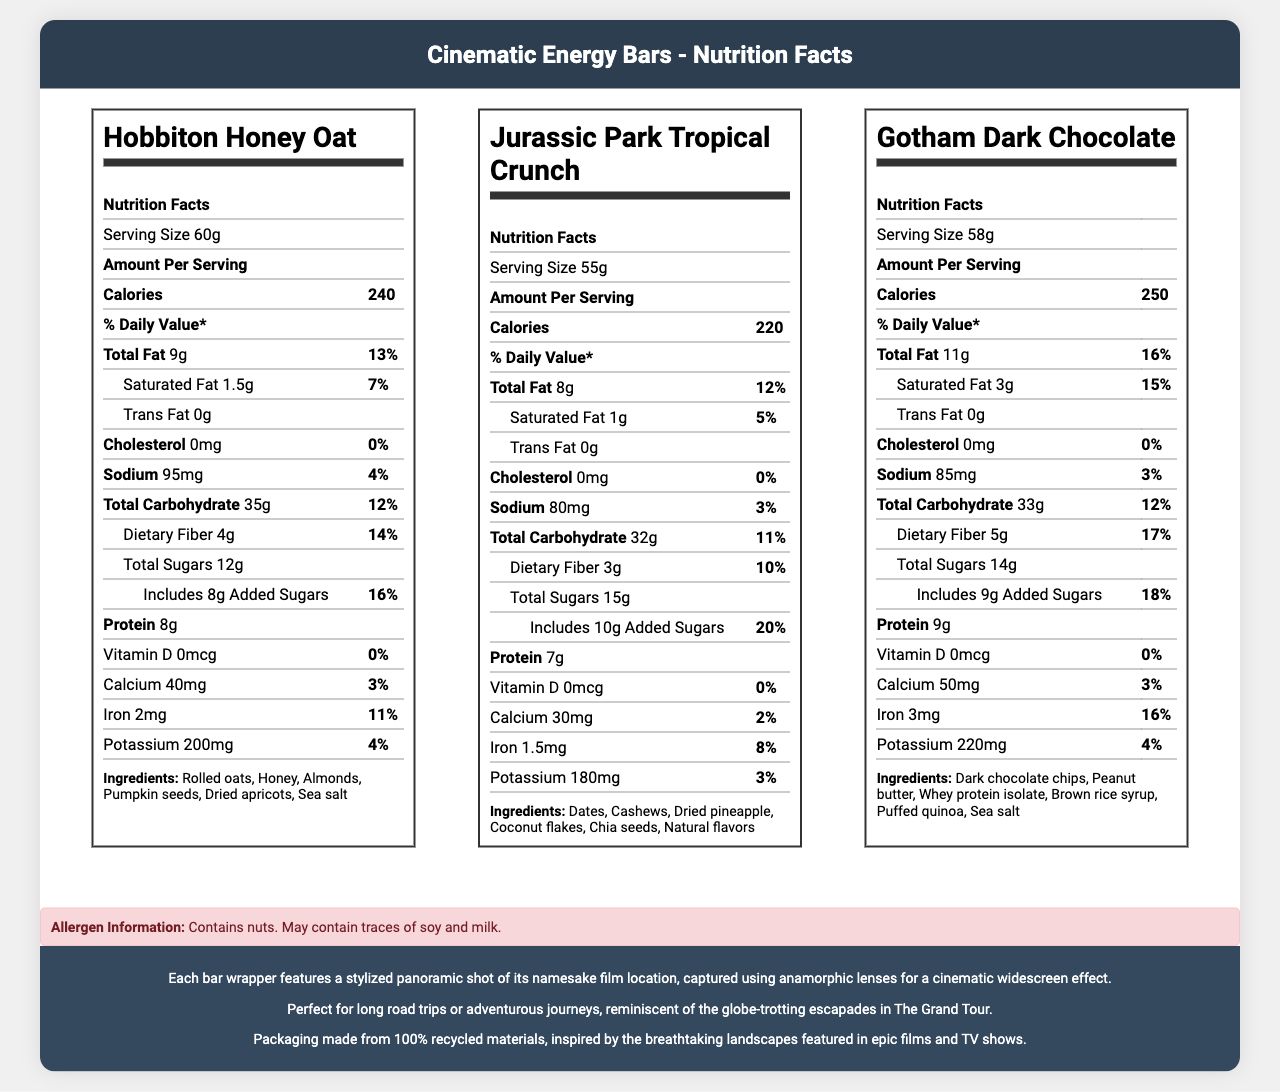what is the serving size of Hobbiton Honey Oat? The serving size is mentioned at the top of the nutritional information for Hobbiton Honey Oat.
Answer: 60g How many calories does the Jurassic Park Tropical Crunch bar have? The number of calories is listed in the nutritional information for the Jurassic Park Tropical Crunch bar.
Answer: 220 What is the protein content of the Gotham Dark Chocolate bar? The protein content is listed in the nutritional information for the Gotham Dark Chocolate bar.
Answer: 9g How much dietary fiber is in the Hobbiton Honey Oat flavor? The dietary fiber content is listed in the nutritional information for the Hobbiton Honey Oat bar.
Answer: 4g What are the main ingredients in the Jurassic Park Tropical Crunch bar? The ingredients are listed at the bottom of the nutritional information for Jurassic Park Tropical Crunch.
Answer: Dates, Cashews, Dried pineapple, Coconut flakes, Chia seeds, Natural flavors Which flavor has the highest amount of total fat? A. Hobbiton Honey Oat B. Jurassic Park Tropical Crunch C. Gotham Dark Chocolate The Gotham Dark Chocolate bar has 11g of total fat, the highest among the three flavors.
Answer: C What percentage of the daily value for calcium does the Gotham Dark Chocolate bar provide? A. 3% B. 4% C. 5% D. 6% The Gotham Dark Chocolate bar provides 5% of the daily value for calcium.
Answer: C Is there any trans fat in the Hobbiton Honey Oat bar? The nutritional information for Hobbiton Honey Oat shows 0g of trans fat.
Answer: No Do the bars contain any allergens? The allergen information section mentions that the bars contain nuts and may contain traces of soy and milk.
Answer: Yes Summarize the main idea of the document. The main idea is that it presents nutritional facts and key details about the Cinematic Energy Bars, their ingredient composition, health-related information, and the concept behind their packaging design.
Answer: The document provides detailed nutritional information for a line of artisanal energy bars named "Cinematic Energy Bars," including three flavors inspired by iconic film locations. It lists the serving sizes, calorie content, nutrient breakdowns, ingredients, and allergen information. The packaging is designed with cinematic inspiration, making the bars ideal for adventurous journeys similar to those in "The Grand Tour." The packaging is also sustainable, made from 100% recycled materials. What is the iron content in the Hobbiton Honey Oat bar? The iron content is listed in the nutritional information for the Hobbiton Honey Oat bar.
Answer: 2mg Which ingredient is common to all three flavors? A. Rolled oats B. Honey C. Sea salt D. Natural flavors Sea salt is listed as an ingredient in all three flavors.
Answer: C How many grams of total sugars are in the Jurassic Park Tropical Crunch bar? The total sugars content is listed in the nutritional information for the Jurassic Park Tropical Crunch bar.
Answer: 15g What percentage of the daily value for sodium does the Hobbiton Honey Oat bar provide? The nutritional information shows that the Hobbiton Honey Oat bar provides 95mg of sodium, which is 4% of the daily value.
Answer: 4% What is the sustainability note mentioned in the document? The sustainability note is mentioned at the bottom of the document, stating that the packaging is environmentally friendly.
Answer: Packaging made from 100% recycled materials, inspired by the breathtaking landscapes featured in epic films and TV shows. What is the display format style used for the packaging of these bars? The document mentions that the bar wrappers feature panoramic shots captured using anamorphic lenses, inspired by the cinematic widescreen effect.
Answer: Anamorphic lenses for a cinematic widescreen effect What is the total carbohydrate content of the Gotham Dark Chocolate bar? The total carbohydrate content is listed in the nutritional information for the Gotham Dark Chocolate bar.
Answer: 33g Is there any vitamin D in the Hobbiton Honey Oat flavor? The nutritional information for Hobbiton Honey Oat shows 0mcg of vitamin D.
Answer: No What inspired the connection to "The Grand Tour" in the product line? The document connects the energy bars to "The Grand Tour" by emphasizing their suitability for long journeys and adventures, similar to the show's theme.
Answer: The bars are perfect for long road trips or adventurous journeys, reminiscent of the globe-trotting escapades in The Grand Tour. Which flavor has the highest amount of added sugars? The Jurassic Park Tropical Crunch bar has 10g of added sugars, the highest among the three flavors.
Answer: Jurassic Park Tropical Crunch How many different ingredients are listed for the Gotham Dark Chocolate bar? The nutritional information lists six ingredients for the Gotham Dark Chocolate bar.
Answer: 6 What is the role of the ingredients section in the nutrition label? The ingredients section provides details on the components used in making each flavor of the energy bars.
Answer: Lists the components used in the energy bars, giving insights into what each flavor consists of. What is the total carbohydrate percentage of the daily value for the Jurassic Park Tropical Crunch bar? The nutritional information shows that the total carbohydrate content is 32g, which is 12% of the daily value.
Answer: 12% Which flavor has the lowest sodium content? The Jurassic Park Tropical Crunch bar has 80mg of sodium, the lowest among the three flavors.
Answer: Jurassic Park Tropical Crunch Who manufactures the Cinematic Energy Bars? The document does not provide any details on the manufacturer of the Cinematic Energy Bars.
Answer: Not enough information 